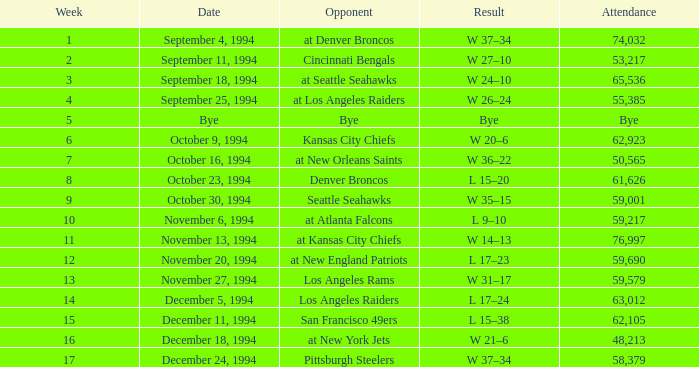In the game where they played the Pittsburgh Steelers, what was the attendance? 58379.0. 